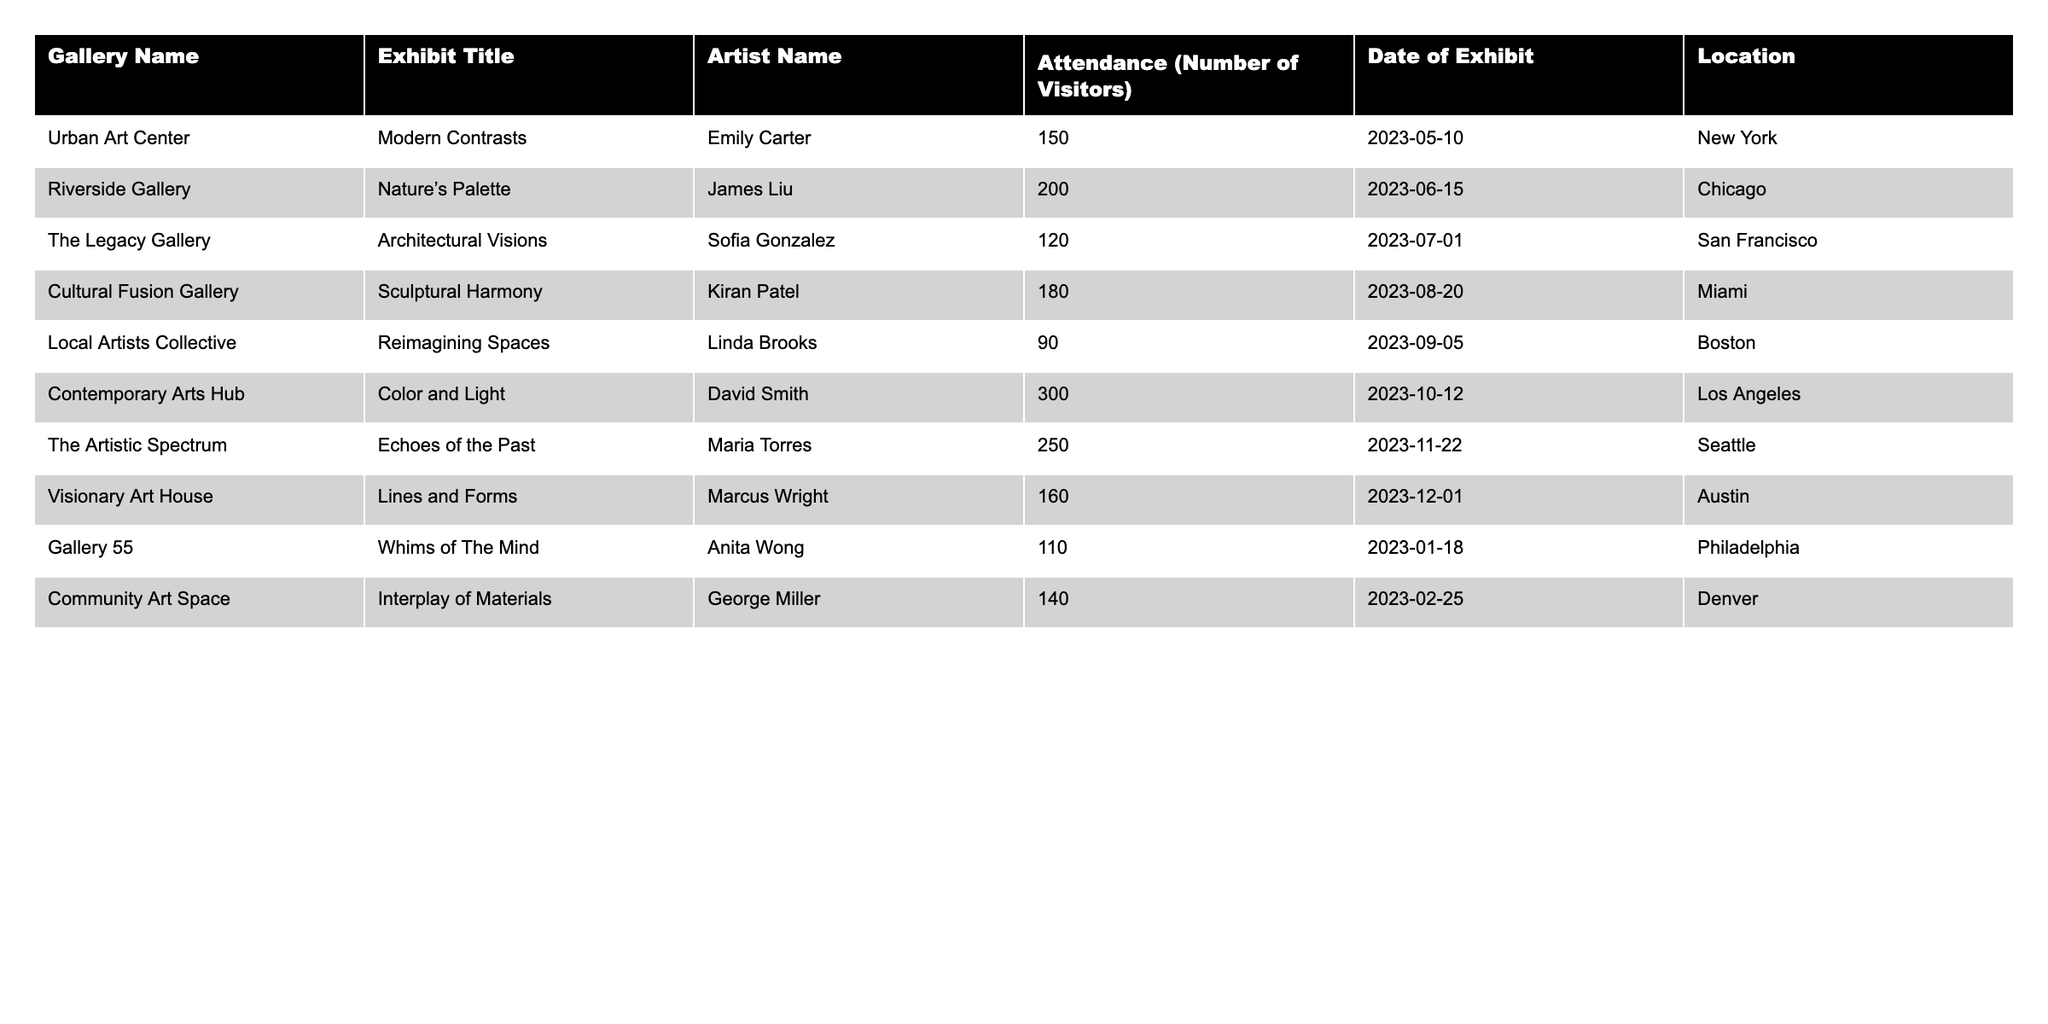What is the name of the artist who had the highest attendance at their exhibit? The exhibit with the highest attendance is "Color and Light" by David Smith, which had 300 visitors.
Answer: David Smith Which gallery hosted the exhibit titled "Architectural Visions"? The exhibit "Architectural Visions" was hosted at The Legacy Gallery.
Answer: The Legacy Gallery What is the total attendance across all exhibits listed in the table? The total attendance is calculated by adding all attendance numbers: 150 + 200 + 120 + 180 + 90 + 300 + 250 + 160 + 110 + 140 = 1,750.
Answer: 1,750 Which exhibit had an attendance of 90 visitors? The exhibit with an attendance of 90 visitors is "Reimagining Spaces" by Linda Brooks.
Answer: "Reimagining Spaces" Is there an exhibit by an artist named "James Liu"? Yes, there is an exhibit titled "Nature’s Palette" by artist James Liu.
Answer: Yes What is the median attendance number among the exhibits? To find the median, first list the attendance numbers in order: 90, 110, 120, 140, 150, 160, 180, 200, 250, 300. Since there are 10 numbers, the median will be the average of the 5th and 6th numbers: (150 + 160)/2 = 155.
Answer: 155 Which city had the exhibit "Interplay of Materials"? The exhibit "Interplay of Materials" took place in Denver.
Answer: Denver What is the difference in attendance between the highest and lowest exhibit? The highest attendance is 300 (Color and Light) and the lowest is 90 (Reimagining Spaces). The difference is 300 - 90 = 210.
Answer: 210 How many exhibits were conducted in the city of Miami? There was one exhibit conducted in Miami, which is "Sculptural Harmony" by Kiran Patel.
Answer: 1 Which artist has exhibits with more than 200 visitors? The artists with exhibits that had more than 200 visitors are David Smith and Maria Torres.
Answer: David Smith and Maria Torres 